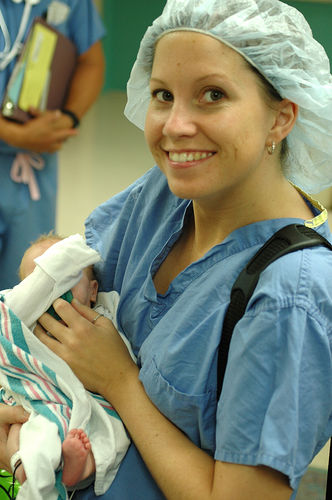What is the overall image quality?
A. Average
B. Excellent
C. Good
D. Poor
Answer with the option's letter from the given choices directly.
 C. 